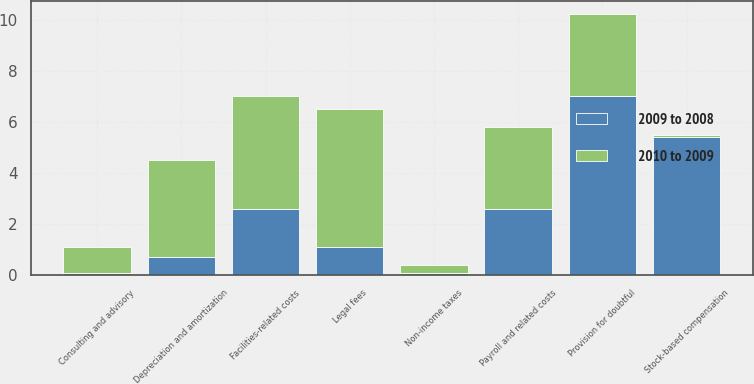Convert chart to OTSL. <chart><loc_0><loc_0><loc_500><loc_500><stacked_bar_chart><ecel><fcel>Payroll and related costs<fcel>Stock-based compensation<fcel>Non-income taxes<fcel>Facilities-related costs<fcel>Depreciation and amortization<fcel>Provision for doubtful<fcel>Legal fees<fcel>Consulting and advisory<nl><fcel>2009 to 2008<fcel>2.6<fcel>5.4<fcel>0.1<fcel>2.6<fcel>0.7<fcel>7<fcel>1.1<fcel>0.1<nl><fcel>2010 to 2009<fcel>3.2<fcel>0.1<fcel>0.3<fcel>4.4<fcel>3.8<fcel>3.2<fcel>5.4<fcel>1<nl></chart> 